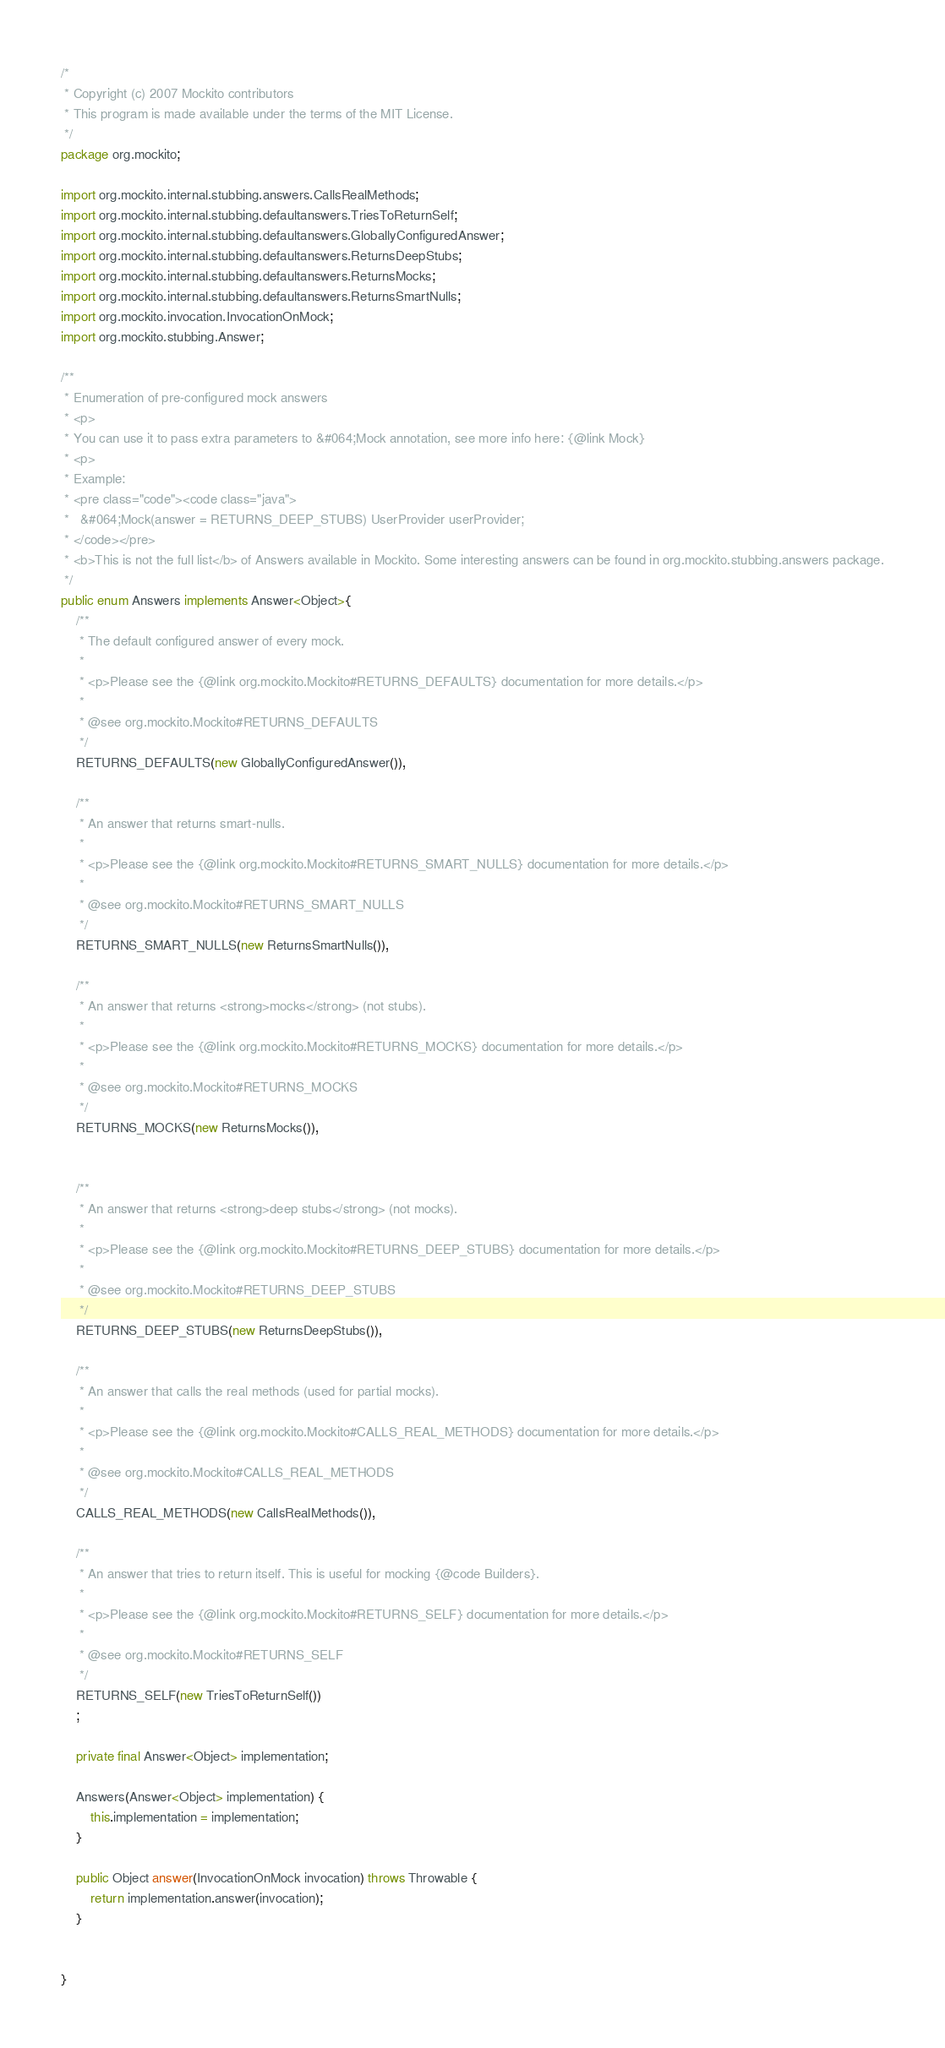<code> <loc_0><loc_0><loc_500><loc_500><_Java_>/*
 * Copyright (c) 2007 Mockito contributors
 * This program is made available under the terms of the MIT License.
 */
package org.mockito;

import org.mockito.internal.stubbing.answers.CallsRealMethods;
import org.mockito.internal.stubbing.defaultanswers.TriesToReturnSelf;
import org.mockito.internal.stubbing.defaultanswers.GloballyConfiguredAnswer;
import org.mockito.internal.stubbing.defaultanswers.ReturnsDeepStubs;
import org.mockito.internal.stubbing.defaultanswers.ReturnsMocks;
import org.mockito.internal.stubbing.defaultanswers.ReturnsSmartNulls;
import org.mockito.invocation.InvocationOnMock;
import org.mockito.stubbing.Answer;

/**
 * Enumeration of pre-configured mock answers
 * <p>
 * You can use it to pass extra parameters to &#064;Mock annotation, see more info here: {@link Mock}
 * <p>
 * Example:
 * <pre class="code"><code class="java">
 *   &#064;Mock(answer = RETURNS_DEEP_STUBS) UserProvider userProvider;
 * </code></pre>
 * <b>This is not the full list</b> of Answers available in Mockito. Some interesting answers can be found in org.mockito.stubbing.answers package.
 */
public enum Answers implements Answer<Object>{
    /**
     * The default configured answer of every mock.
     *
     * <p>Please see the {@link org.mockito.Mockito#RETURNS_DEFAULTS} documentation for more details.</p>
     *
     * @see org.mockito.Mockito#RETURNS_DEFAULTS
     */
    RETURNS_DEFAULTS(new GloballyConfiguredAnswer()),

    /**
     * An answer that returns smart-nulls.
     *
     * <p>Please see the {@link org.mockito.Mockito#RETURNS_SMART_NULLS} documentation for more details.</p>
     *
     * @see org.mockito.Mockito#RETURNS_SMART_NULLS
     */
    RETURNS_SMART_NULLS(new ReturnsSmartNulls()),

    /**
     * An answer that returns <strong>mocks</strong> (not stubs).
     *
     * <p>Please see the {@link org.mockito.Mockito#RETURNS_MOCKS} documentation for more details.</p>
     *
     * @see org.mockito.Mockito#RETURNS_MOCKS
     */
    RETURNS_MOCKS(new ReturnsMocks()),


    /**
     * An answer that returns <strong>deep stubs</strong> (not mocks).
     *
     * <p>Please see the {@link org.mockito.Mockito#RETURNS_DEEP_STUBS} documentation for more details.</p>
     *
     * @see org.mockito.Mockito#RETURNS_DEEP_STUBS
     */
    RETURNS_DEEP_STUBS(new ReturnsDeepStubs()),

    /**
     * An answer that calls the real methods (used for partial mocks).
     *
     * <p>Please see the {@link org.mockito.Mockito#CALLS_REAL_METHODS} documentation for more details.</p>
     *
     * @see org.mockito.Mockito#CALLS_REAL_METHODS
     */
    CALLS_REAL_METHODS(new CallsRealMethods()),

    /**
     * An answer that tries to return itself. This is useful for mocking {@code Builders}.
     *
     * <p>Please see the {@link org.mockito.Mockito#RETURNS_SELF} documentation for more details.</p>
     *
     * @see org.mockito.Mockito#RETURNS_SELF
     */
    RETURNS_SELF(new TriesToReturnSelf())
    ;

    private final Answer<Object> implementation;

    Answers(Answer<Object> implementation) {
        this.implementation = implementation;
    }

    public Object answer(InvocationOnMock invocation) throws Throwable {
        return implementation.answer(invocation);
    }

   
}
</code> 